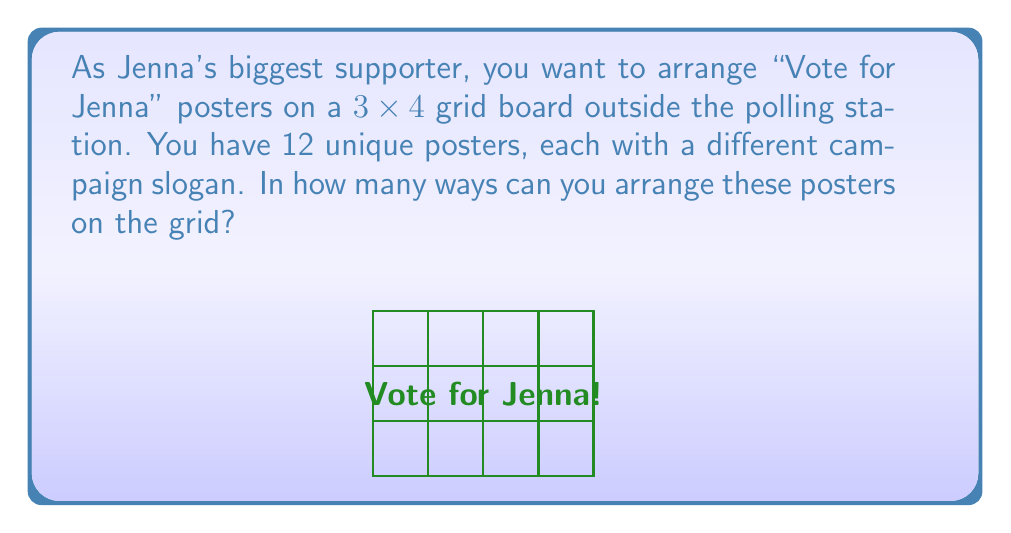Can you solve this math problem? Let's approach this step-by-step:

1) We have a $3 \times 4$ grid, which means there are 12 positions to fill.

2) We also have 12 unique posters, each of which must be used exactly once.

3) This scenario is equivalent to arranging 12 distinct objects in 12 distinct positions.

4) In combinatorics, this is a permutation of 12 objects.

5) The number of permutations of n distinct objects is given by $n!$ (n factorial).

6) In this case, $n = 12$.

7) Therefore, the number of unique arrangements is $12!$.

8) $12! = 12 \times 11 \times 10 \times 9 \times 8 \times 7 \times 6 \times 5 \times 4 \times 3 \times 2 \times 1$

9) $12! = 479,001,600$

Thus, there are 479,001,600 unique ways to arrange the "Vote for Jenna" posters on the grid.
Answer: $12! = 479,001,600$ 